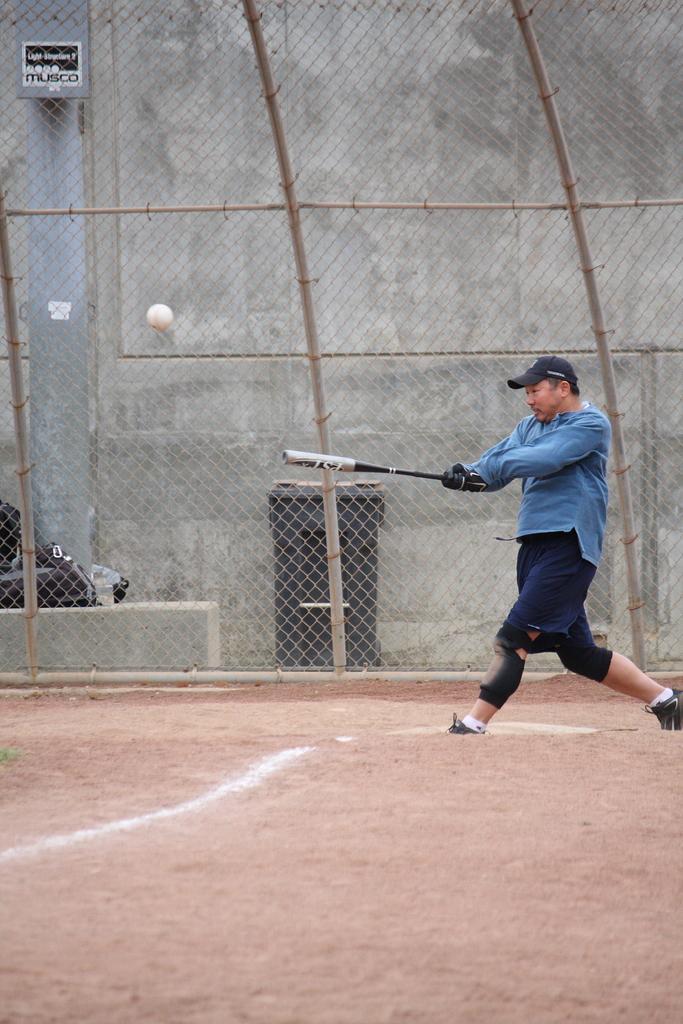Could you give a brief overview of what you see in this image? In this image I can see the person with the dress and the cap and also holding the baseball bat. I can see the ball in the air. In the background I can see the net fence, black color object, board and the building. 